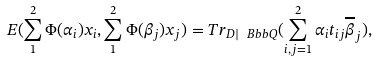Convert formula to latex. <formula><loc_0><loc_0><loc_500><loc_500>E ( \sum _ { 1 } ^ { 2 } \Phi ( \alpha _ { i } ) x _ { i } , \sum _ { 1 } ^ { 2 } \Phi ( \beta _ { j } ) x _ { j } ) = T r _ { D | { \ B b b Q } } ( \sum _ { i , j = 1 } ^ { 2 } \alpha _ { i } t _ { i j } \overline { \beta } _ { j } ) ,</formula> 